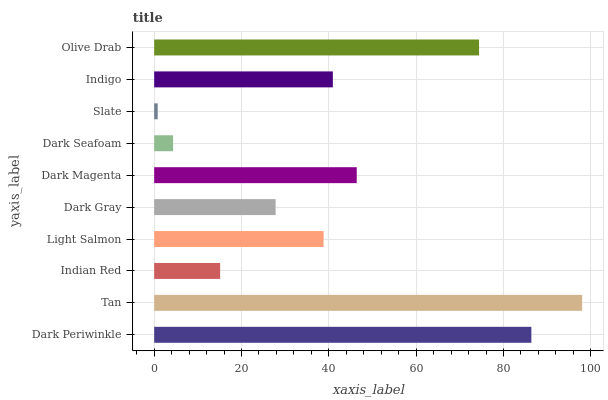Is Slate the minimum?
Answer yes or no. Yes. Is Tan the maximum?
Answer yes or no. Yes. Is Indian Red the minimum?
Answer yes or no. No. Is Indian Red the maximum?
Answer yes or no. No. Is Tan greater than Indian Red?
Answer yes or no. Yes. Is Indian Red less than Tan?
Answer yes or no. Yes. Is Indian Red greater than Tan?
Answer yes or no. No. Is Tan less than Indian Red?
Answer yes or no. No. Is Indigo the high median?
Answer yes or no. Yes. Is Light Salmon the low median?
Answer yes or no. Yes. Is Slate the high median?
Answer yes or no. No. Is Indian Red the low median?
Answer yes or no. No. 